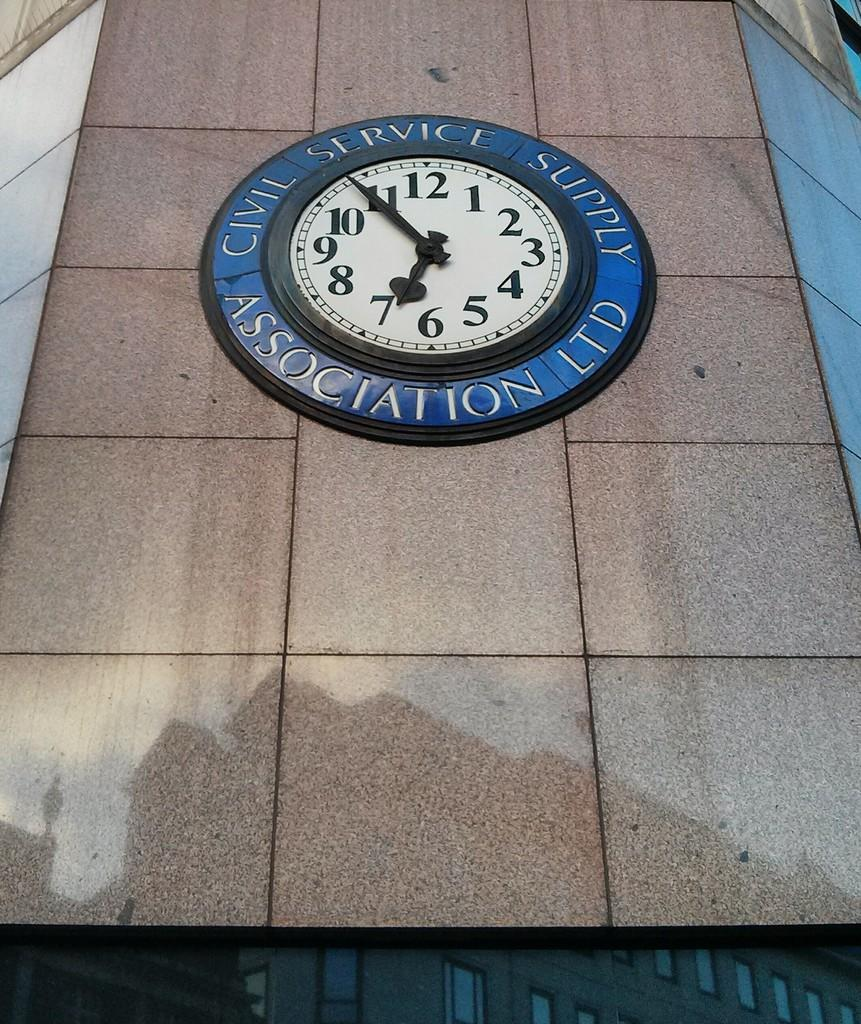<image>
Relay a brief, clear account of the picture shown. The clock on the building is set at 6:54. 